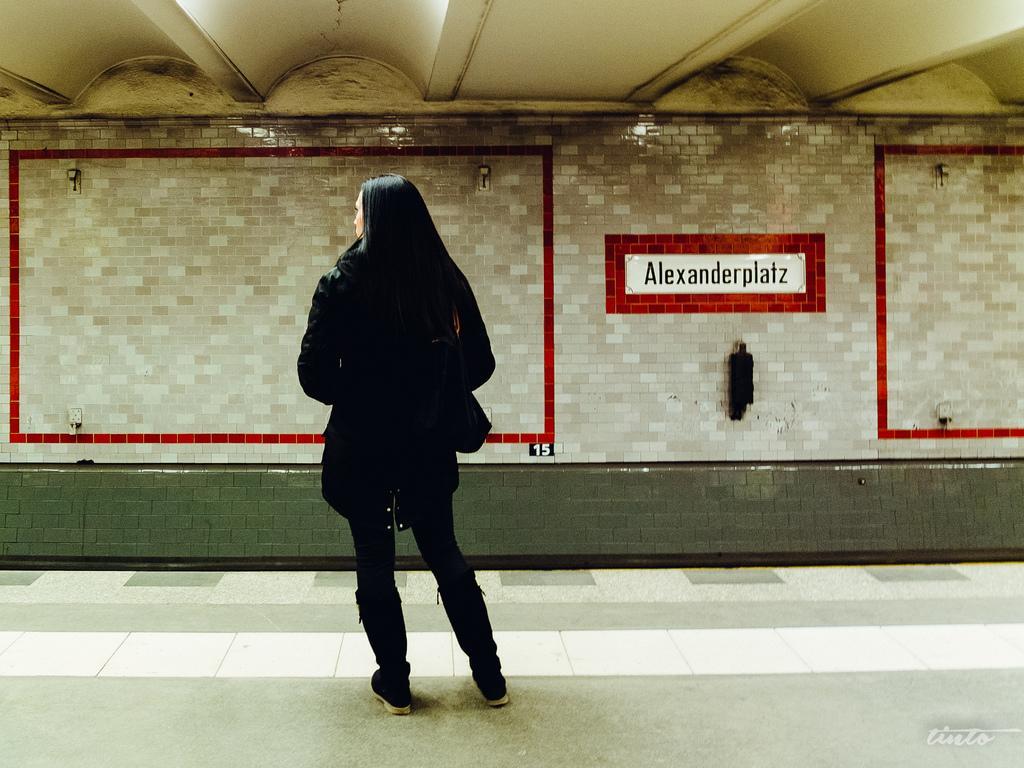Please provide a concise description of this image. In the image I can see a woman standing facing towards the back. I can see a wall in front of her with some tiles and there is a sticker on the wall with some text. I can see an object hanging below the sticker. 